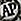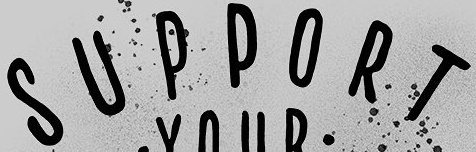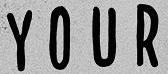What text appears in these images from left to right, separated by a semicolon? AP; SUPPORT; YOUR 